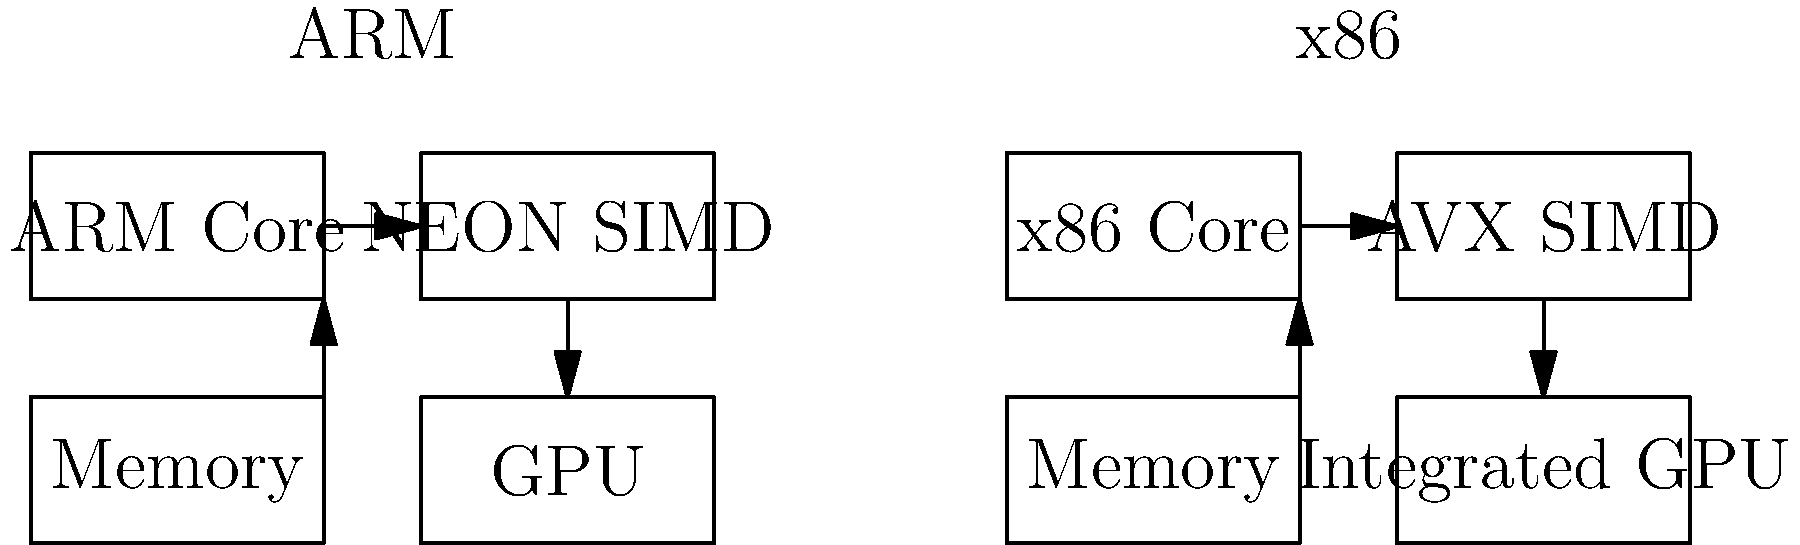As an Android app developer, you're considering hardware compatibility for a new computationally intensive app. Based on the block diagrams of ARM and x86 architectures shown above, which key difference in SIMD (Single Instruction, Multiple Data) implementation would most likely impact your app's performance on different devices? To answer this question, let's analyze the block diagrams and their implications for Android app development:

1. Both architectures show a core processor, memory, and GPU components.

2. The key difference lies in the SIMD (Single Instruction, Multiple Data) implementation:
   - ARM architecture uses NEON SIMD
   - x86 architecture uses AVX (Advanced Vector Extensions) SIMD

3. SIMD instructions are crucial for parallel processing, which is often used in computationally intensive tasks such as image and video processing, or complex calculations.

4. NEON is ARM's SIMD architecture extension, designed for mobile and embedded systems. It's optimized for power efficiency and mobile workloads.

5. AVX is Intel's SIMD implementation for x86 processors, typically found in desktop and laptop computers. It's generally more powerful but also more power-hungry.

6. As an Android developer, you need to consider that:
   - Most Android devices use ARM processors, so NEON optimization would benefit the majority of your users.
   - Some Android devices (less common) use x86 processors, which would benefit from AVX optimization.

7. The performance impact comes from the different instruction sets and capabilities of NEON vs. AVX. Code optimized for one may not run optimally on the other.

8. To ensure best performance across devices, you might need to implement architecture-specific code paths or use libraries that handle this automatically.

Therefore, the key difference in SIMD implementation (NEON vs. AVX) would most likely impact your app's performance on different devices, requiring careful consideration in your development process.
Answer: NEON vs. AVX SIMD implementations 